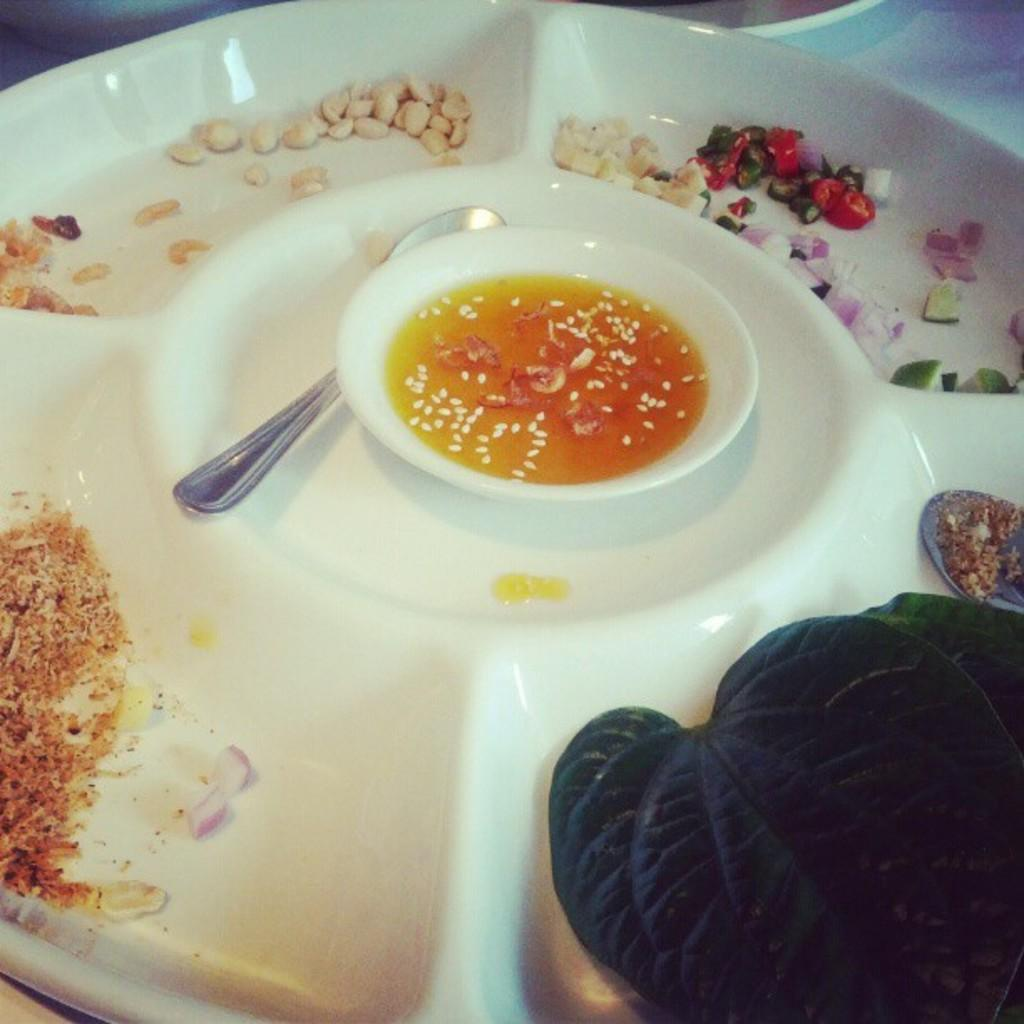What is on the plate in the image? There is a bowl with soup on the plate. What is used for eating the soup in the image? There is a spoon beside the bowl. What type of vegetation is present in the image? There are leaves in the image. What is the powder used for in the image? The purpose of the powder is not specified in the image. What type of food is visible in the image? There are vegetable slices and grains in the image. Where is the wheel located in the image? There is no wheel present in the image. What type of nest can be seen in the image? There is no nest present in the image. 